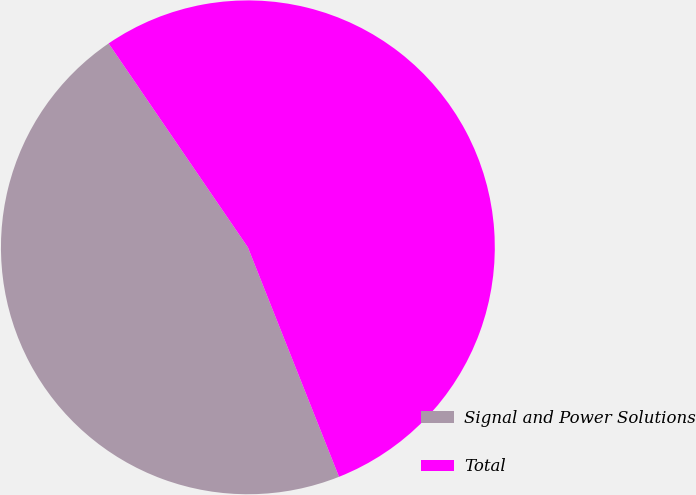Convert chart. <chart><loc_0><loc_0><loc_500><loc_500><pie_chart><fcel>Signal and Power Solutions<fcel>Total<nl><fcel>46.48%<fcel>53.52%<nl></chart> 